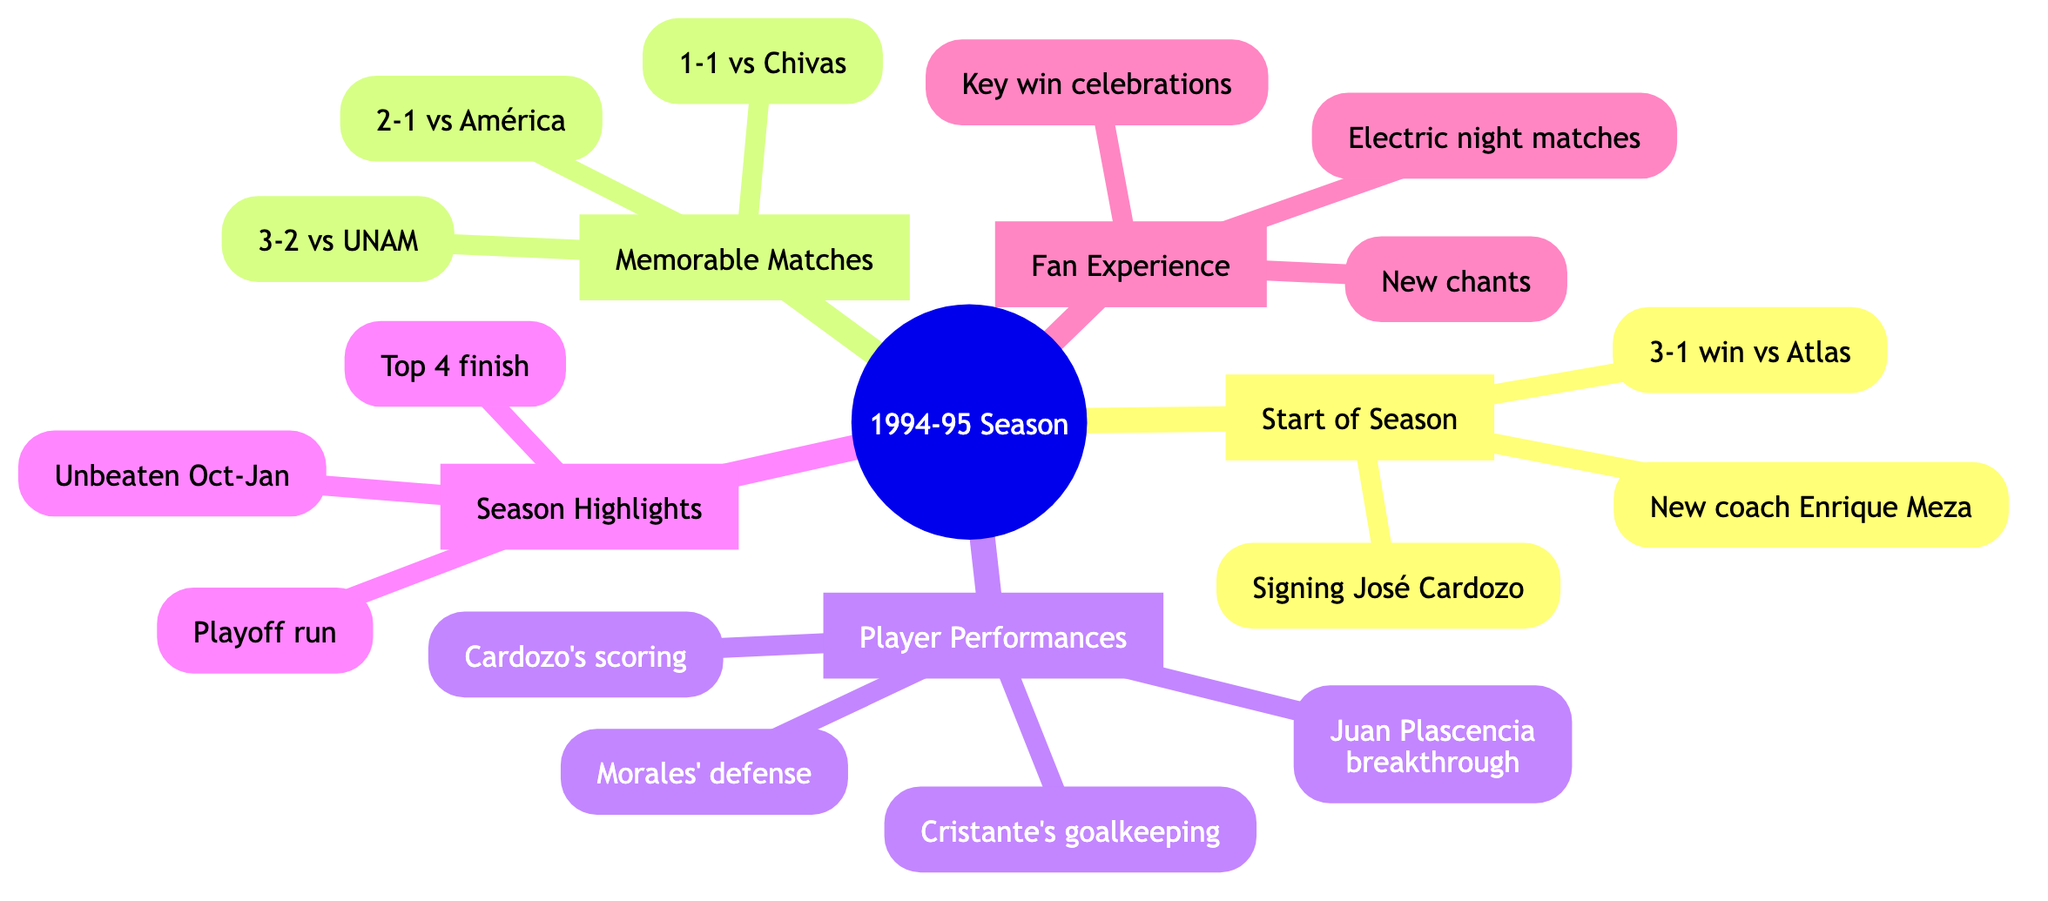What highlights marked the start of the season? The "Start of the Season" node contains two main highlights: the welcoming of new coach Enrique Meza and the signing of José Saturnino Cardozo. Both highlights are listed under that category.
Answer: New coach Enrique Meza, signing José Saturnino Cardozo How many key matches are listed in the diagram? The "Memorable Matches" section contains three distinct matches: against Club América, against Chivas, and the derby against UNAM. Therefore, there are three key matches in total.
Answer: 3 What was the outcome of the match against Club América? The summary provided under "Against Club América" indicates that the outcome of the match was a thrilling 2-1 victory for Deportivo Toluca, highlighting the significance of this win.
Answer: 2-1 victory Which player is noted for their goal-scoring prowess? Under "Key Players," the player noted for their goal-scoring prowess is José Saturnino Cardozo, as clearly stated in that section.
Answer: José Saturnino Cardozo What was the team's league standing at the end of the regular season? The "Season Highlights" section specifies that the team achieved a top 4 finish in the regular season, indicating their competitive performance throughout.
Answer: Top 4 finish What was the impact of the 3-2 derby win against UNAM? The impact noted in the diagram for the 3-2 comeback win against UNAM is that it reinforced rivalry and fan support, demonstrating the significance of this match beyond just the scoreline.
Answer: Reinforced rivalry and fan support What notable moments are mentioned under fan experience? The "Notable Moments" in the "Fan Experience" section include celebrations after key wins and unwavering fan support throughout the season, illustrating the strong connection between the fans and the team.
Answer: Celebrations after key wins, unwavering fan support What did the team achieve during the mid-season form? The diagram states that during the mid-season form, the team had an unbeaten streak from October to January, showcasing their strong performance during that period.
Answer: Unbeaten streak from October to January 